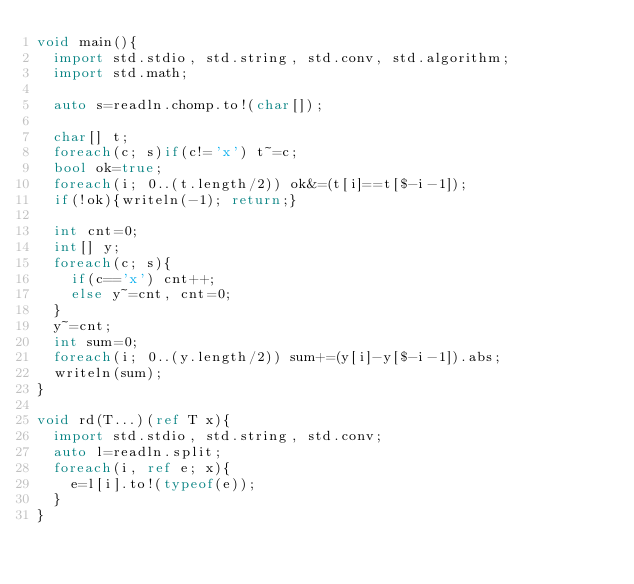<code> <loc_0><loc_0><loc_500><loc_500><_D_>void main(){
  import std.stdio, std.string, std.conv, std.algorithm;
  import std.math;
  
  auto s=readln.chomp.to!(char[]);

  char[] t;
  foreach(c; s)if(c!='x') t~=c;
  bool ok=true;
  foreach(i; 0..(t.length/2)) ok&=(t[i]==t[$-i-1]);
  if(!ok){writeln(-1); return;}

  int cnt=0;
  int[] y;
  foreach(c; s){
    if(c=='x') cnt++;
    else y~=cnt, cnt=0;
  }
  y~=cnt;
  int sum=0;
  foreach(i; 0..(y.length/2)) sum+=(y[i]-y[$-i-1]).abs;
  writeln(sum);
}

void rd(T...)(ref T x){
  import std.stdio, std.string, std.conv;
  auto l=readln.split;
  foreach(i, ref e; x){
    e=l[i].to!(typeof(e));
  }
}</code> 